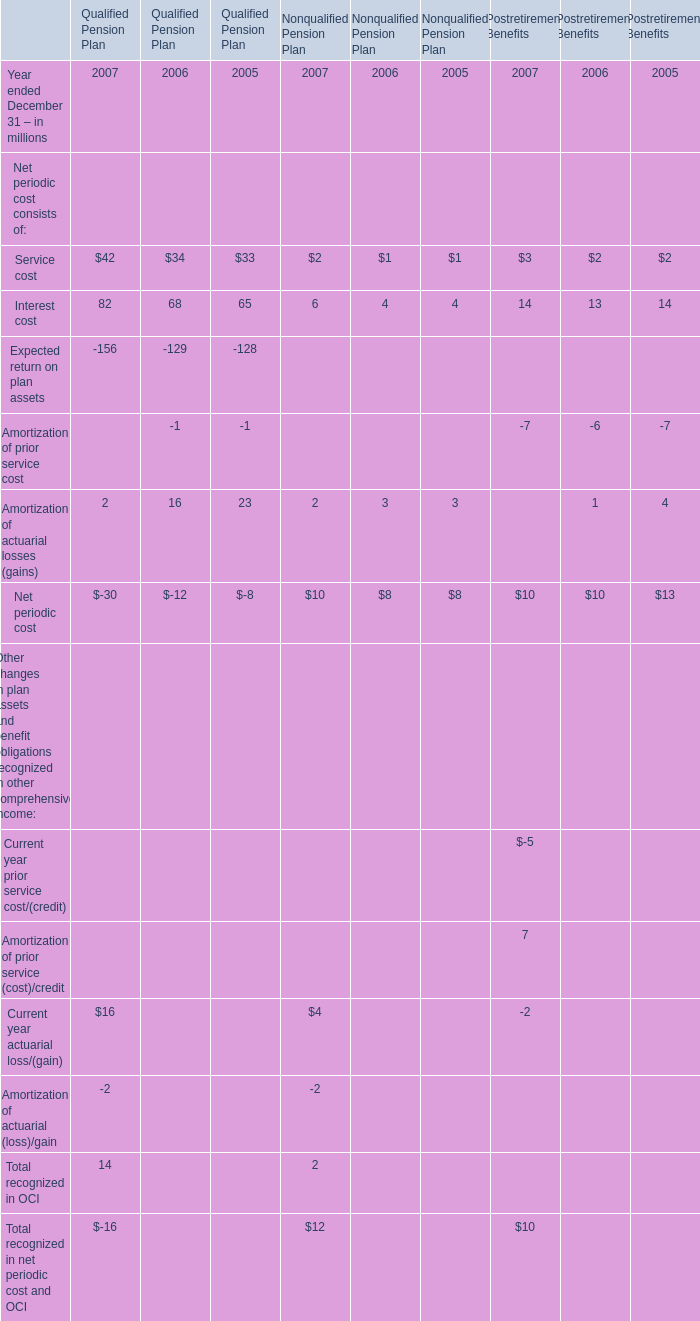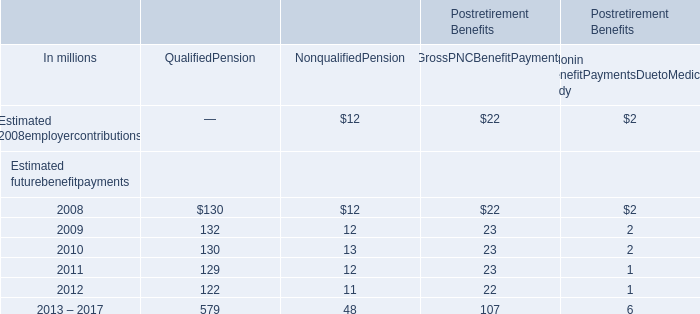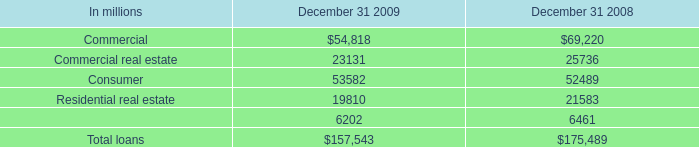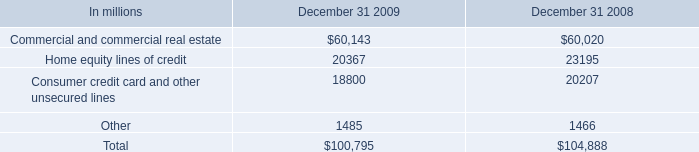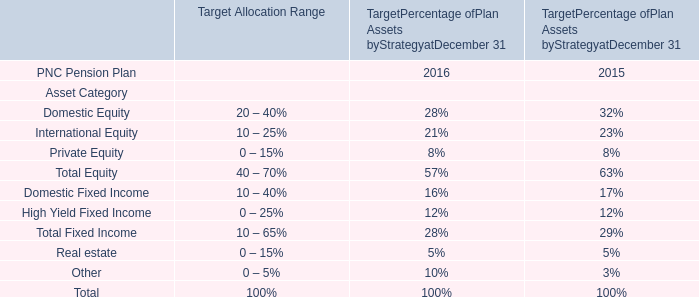What is the ratio of all Estimated futurebenefitpayments that are smaller than 20 to the sum of Estimated futurebenefitpayments, in 2008? 
Computations: ((12 + 2) / (((12 + 22) + 2) + 130))
Answer: 0.08434. 